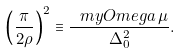Convert formula to latex. <formula><loc_0><loc_0><loc_500><loc_500>\left ( \frac { \pi } { 2 \rho } \right ) ^ { 2 } \equiv \frac { \ m y O m e g a \, \mu } { \Delta _ { 0 } ^ { 2 } } .</formula> 